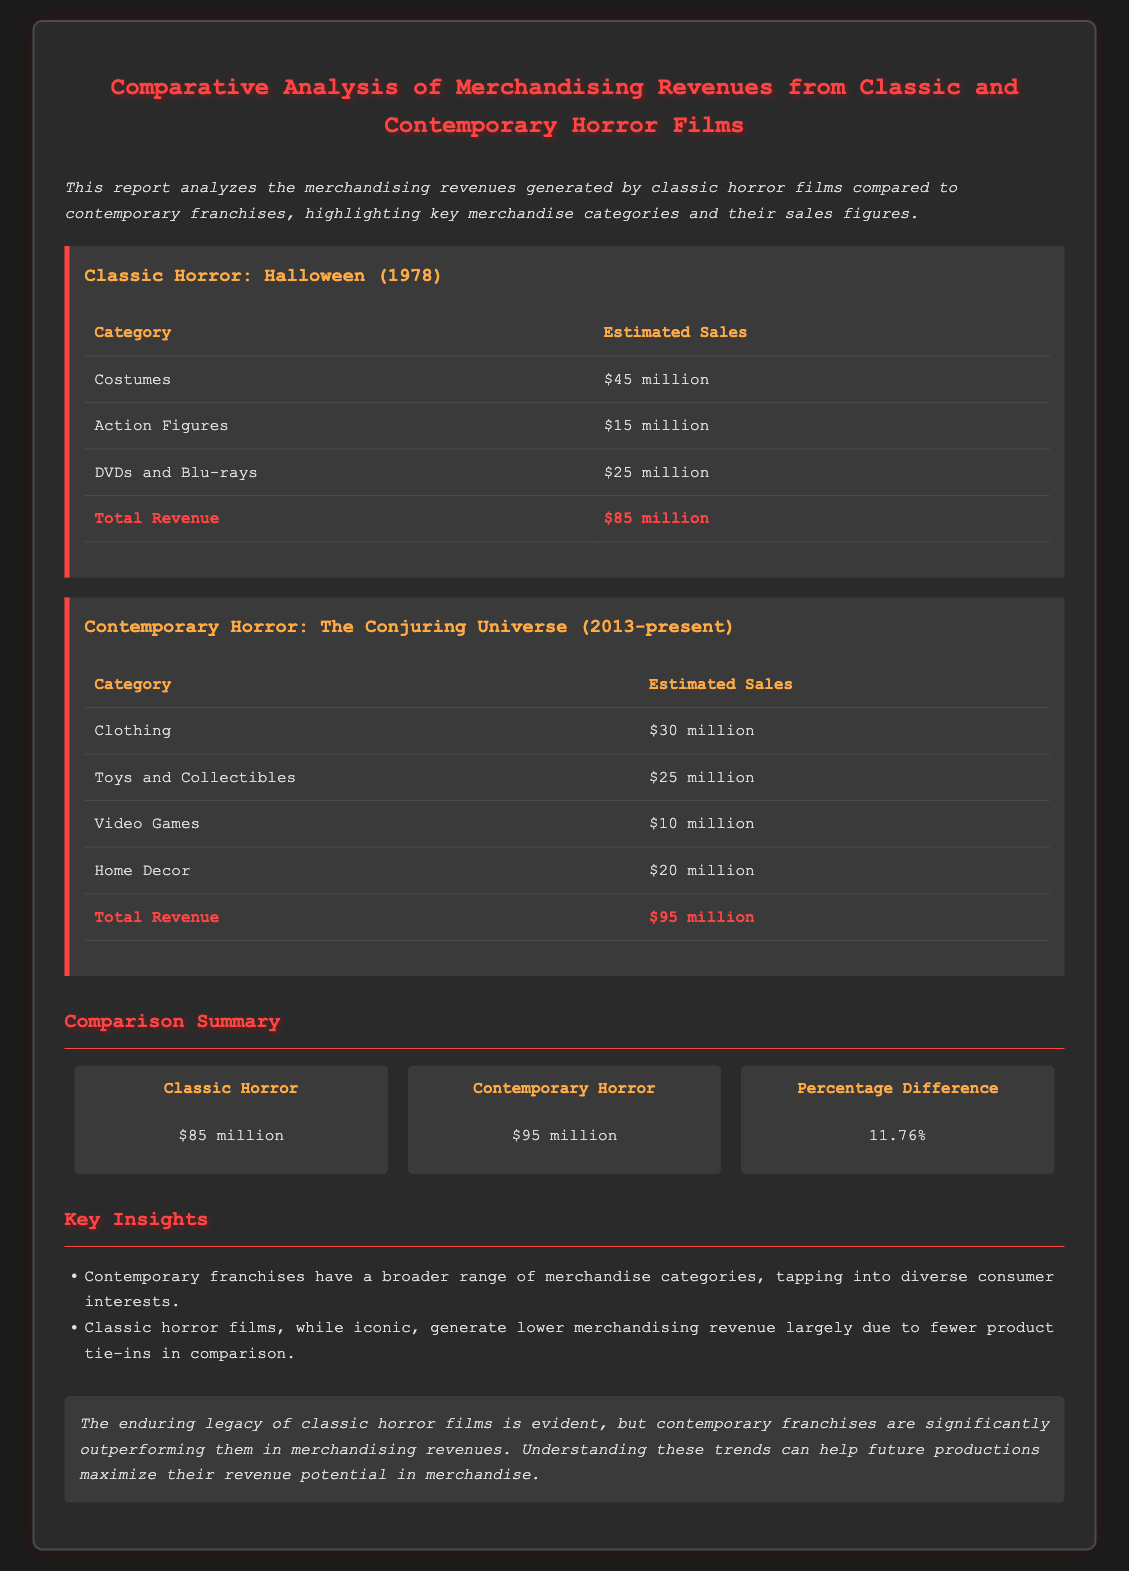What is the total revenue for Halloween (1978)? The total revenue for Halloween (1978) is listed as $85 million, collected from various merchandise categories.
Answer: $85 million What is the total revenue for The Conjuring Universe? The total revenue for The Conjuring Universe is provided as $95 million, which includes multiple merchandise sales.
Answer: $95 million Which merchandise category generated the most sales for Halloween (1978)? The merchandise category with the most sales for Halloween (1978) is Costumes, contributing $45 million to the total.
Answer: Costumes What is the percentage difference in total revenue between classic and contemporary horror? The percentage difference calculated between their revenues is 11.76%, indicating how much more contemporary horror earns compared to classic horror.
Answer: 11.76% How much did Clothing merchandise sales generate for The Conjuring Universe? The report states that Clothing merchandise sales for The Conjuring Universe generated $30 million in revenue.
Answer: $30 million What are the total estimated sales from Action Figures for Halloween (1978)? The estimated sales from Action Figures for Halloween (1978) is presented as $15 million, part of the total merchandise revenue.
Answer: $15 million What unique insight is provided regarding contemporary horror franchises? One key insight is that contemporary franchises have a broader range of merchandise categories, reflecting their adaptability to consumer interests.
Answer: Broader range of merchandise categories What does the conclusion state regarding classic horror films? The conclusion emphasizes that while classic horror films have an enduring legacy, they fall short in merchandising revenues compared to contemporary franchises.
Answer: Enduring legacy but lower revenue 